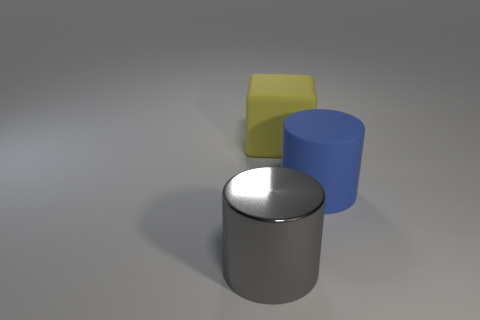Subtract all blue cylinders. How many cylinders are left? 1 Add 2 large blue matte things. How many objects exist? 5 Subtract all purple cylinders. Subtract all yellow balls. How many cylinders are left? 2 Subtract all small rubber objects. Subtract all blue cylinders. How many objects are left? 2 Add 2 large matte cylinders. How many large matte cylinders are left? 3 Add 3 tiny blue metal cylinders. How many tiny blue metal cylinders exist? 3 Subtract 0 green blocks. How many objects are left? 3 Subtract all cylinders. How many objects are left? 1 